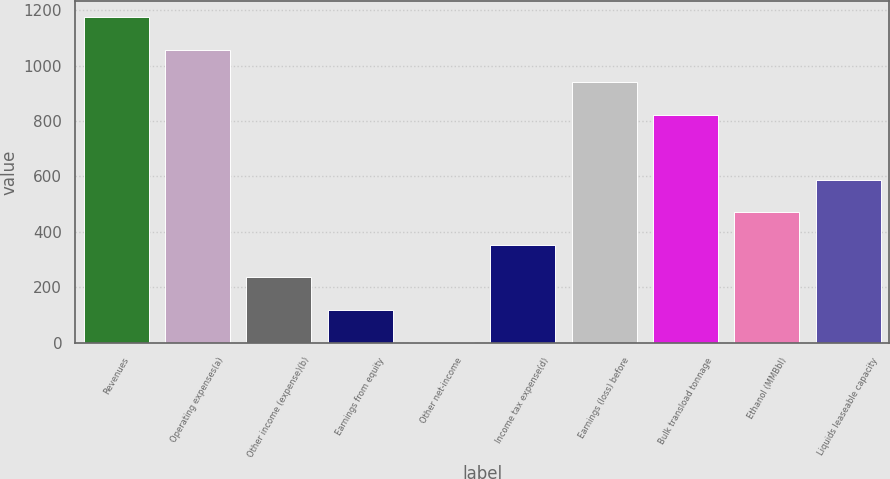Convert chart. <chart><loc_0><loc_0><loc_500><loc_500><bar_chart><fcel>Revenues<fcel>Operating expenses(a)<fcel>Other income (expense)(b)<fcel>Earnings from equity<fcel>Other net-income<fcel>Income tax expense(d)<fcel>Earnings (loss) before<fcel>Bulk transload tonnage<fcel>Ethanol (MMBbl)<fcel>Liquids leaseable capacity<nl><fcel>1173.6<fcel>1056.41<fcel>236.08<fcel>118.89<fcel>1.7<fcel>353.27<fcel>939.22<fcel>822.03<fcel>470.46<fcel>587.65<nl></chart> 